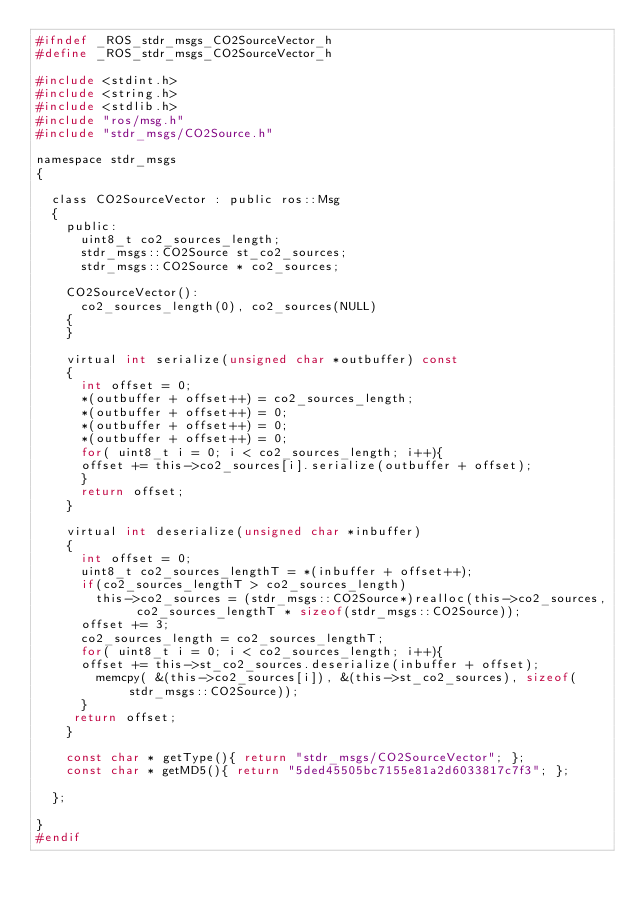Convert code to text. <code><loc_0><loc_0><loc_500><loc_500><_C_>#ifndef _ROS_stdr_msgs_CO2SourceVector_h
#define _ROS_stdr_msgs_CO2SourceVector_h

#include <stdint.h>
#include <string.h>
#include <stdlib.h>
#include "ros/msg.h"
#include "stdr_msgs/CO2Source.h"

namespace stdr_msgs
{

  class CO2SourceVector : public ros::Msg
  {
    public:
      uint8_t co2_sources_length;
      stdr_msgs::CO2Source st_co2_sources;
      stdr_msgs::CO2Source * co2_sources;

    CO2SourceVector():
      co2_sources_length(0), co2_sources(NULL)
    {
    }

    virtual int serialize(unsigned char *outbuffer) const
    {
      int offset = 0;
      *(outbuffer + offset++) = co2_sources_length;
      *(outbuffer + offset++) = 0;
      *(outbuffer + offset++) = 0;
      *(outbuffer + offset++) = 0;
      for( uint8_t i = 0; i < co2_sources_length; i++){
      offset += this->co2_sources[i].serialize(outbuffer + offset);
      }
      return offset;
    }

    virtual int deserialize(unsigned char *inbuffer)
    {
      int offset = 0;
      uint8_t co2_sources_lengthT = *(inbuffer + offset++);
      if(co2_sources_lengthT > co2_sources_length)
        this->co2_sources = (stdr_msgs::CO2Source*)realloc(this->co2_sources, co2_sources_lengthT * sizeof(stdr_msgs::CO2Source));
      offset += 3;
      co2_sources_length = co2_sources_lengthT;
      for( uint8_t i = 0; i < co2_sources_length; i++){
      offset += this->st_co2_sources.deserialize(inbuffer + offset);
        memcpy( &(this->co2_sources[i]), &(this->st_co2_sources), sizeof(stdr_msgs::CO2Source));
      }
     return offset;
    }

    const char * getType(){ return "stdr_msgs/CO2SourceVector"; };
    const char * getMD5(){ return "5ded45505bc7155e81a2d6033817c7f3"; };

  };

}
#endif</code> 